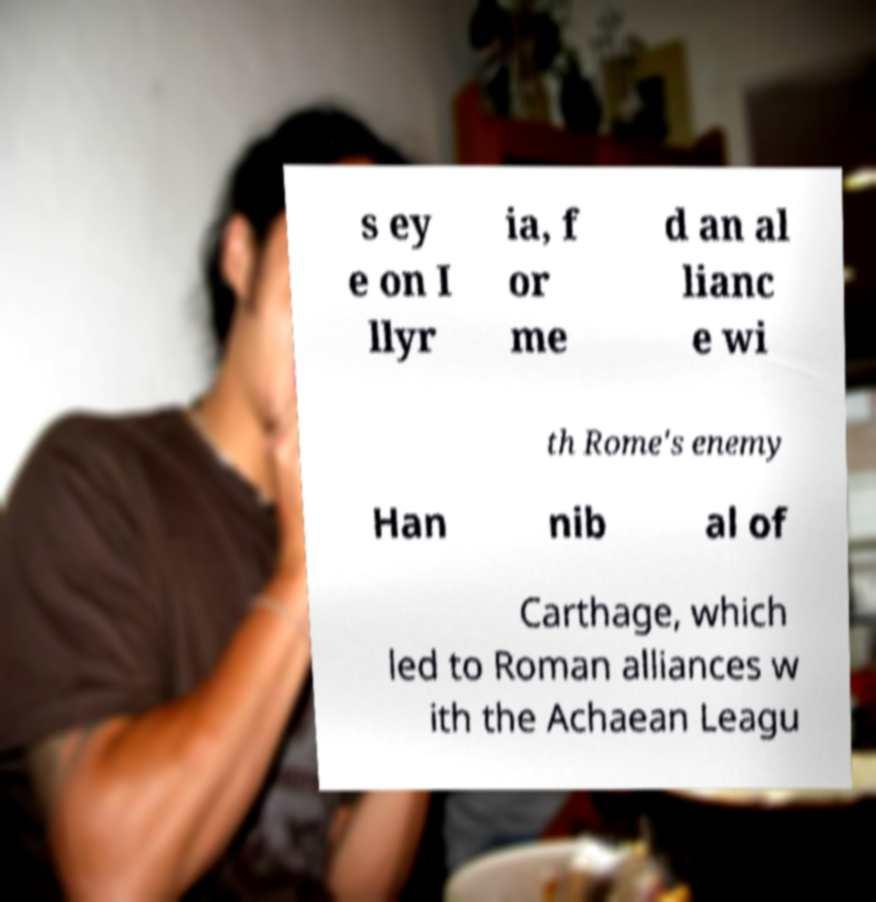For documentation purposes, I need the text within this image transcribed. Could you provide that? s ey e on I llyr ia, f or me d an al lianc e wi th Rome's enemy Han nib al of Carthage, which led to Roman alliances w ith the Achaean Leagu 